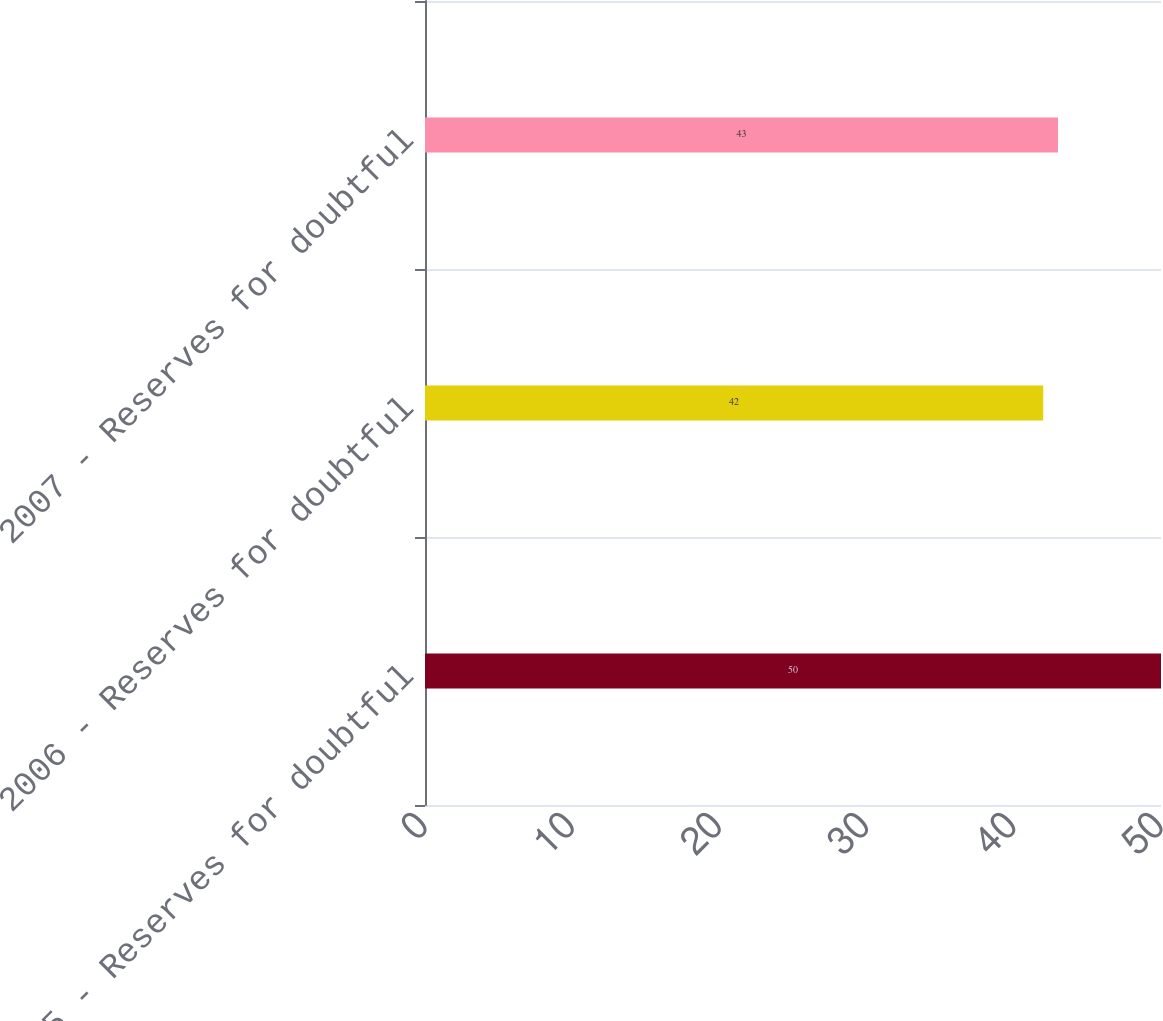Convert chart. <chart><loc_0><loc_0><loc_500><loc_500><bar_chart><fcel>2005 - Reserves for doubtful<fcel>2006 - Reserves for doubtful<fcel>2007 - Reserves for doubtful<nl><fcel>50<fcel>42<fcel>43<nl></chart> 